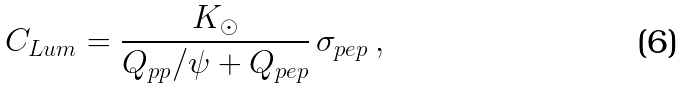Convert formula to latex. <formula><loc_0><loc_0><loc_500><loc_500>C _ { L u m } = \frac { K _ { \odot } } { Q _ { p p } / \psi + Q _ { p e p } } \, \sigma _ { p e p } \, ,</formula> 